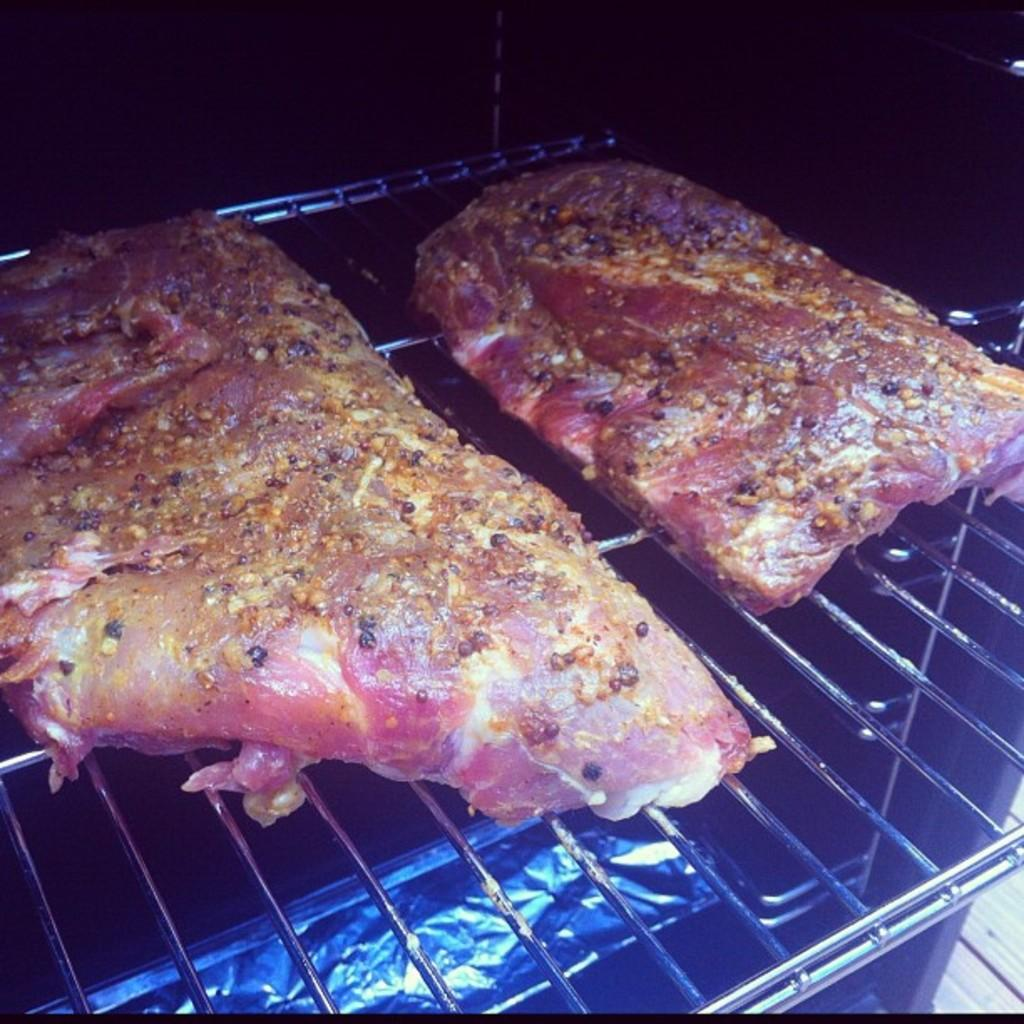What is being cooked on the grill in the image? There is meat on a grill in the image. Can you hear a whistle in the image? There is no mention of a whistle in the image, so it cannot be heard. 